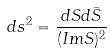<formula> <loc_0><loc_0><loc_500><loc_500>d s ^ { 2 } = \frac { d S d \bar { S } } { ( I m S ) ^ { 2 } }</formula> 